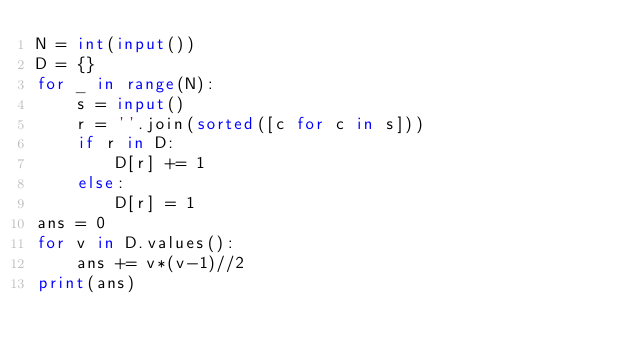<code> <loc_0><loc_0><loc_500><loc_500><_Python_>N = int(input())
D = {}
for _ in range(N):
    s = input()
    r = ''.join(sorted([c for c in s]))
    if r in D:
        D[r] += 1
    else:
        D[r] = 1
ans = 0
for v in D.values():
    ans += v*(v-1)//2
print(ans)
</code> 